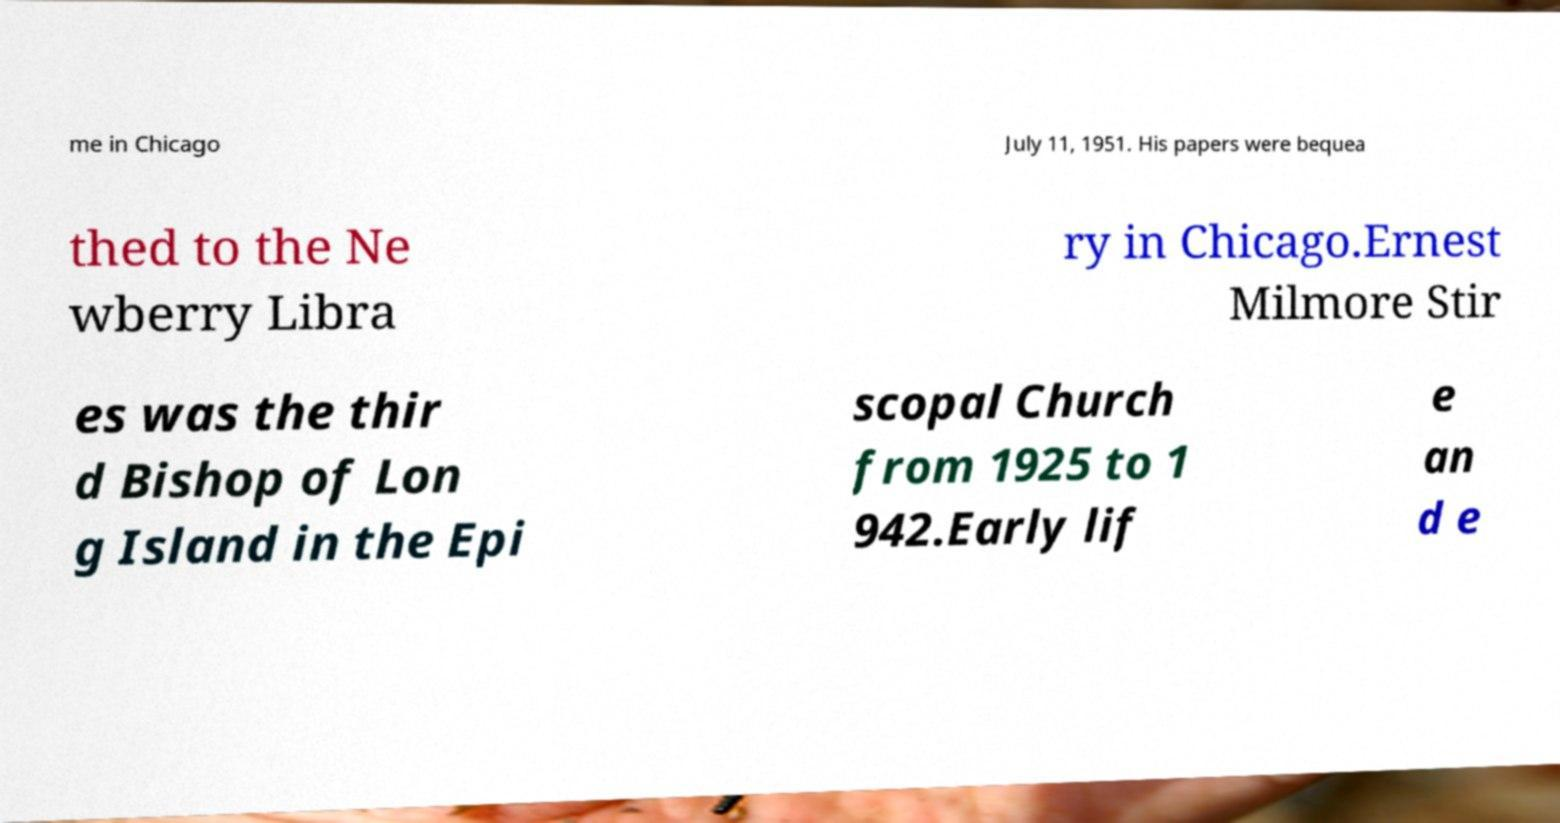Please read and relay the text visible in this image. What does it say? me in Chicago July 11, 1951. His papers were bequea thed to the Ne wberry Libra ry in Chicago.Ernest Milmore Stir es was the thir d Bishop of Lon g Island in the Epi scopal Church from 1925 to 1 942.Early lif e an d e 